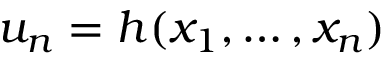<formula> <loc_0><loc_0><loc_500><loc_500>u _ { n } = h ( x _ { 1 } , \dots , x _ { n } )</formula> 